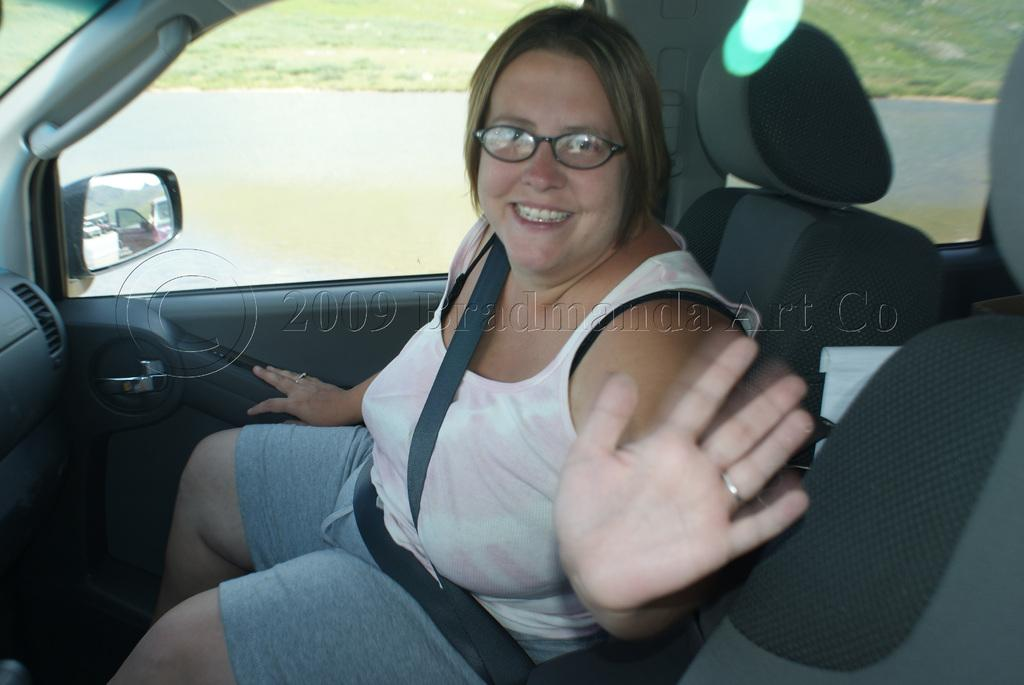Who is present in the image? There is a woman in the image. What is the woman doing in the image? The woman is sitting in the image. What is the woman's facial expression in the image? The woman is smiling in the image. What type of setting is the image depicting? The image is an inside view of a car. What can be seen in the background of the image? There is a road and grass visible in the background of the image. What type of cave can be seen in the background of the image? There is no cave present in the image; it is an inside view of a car with a road and grass visible in the background. 